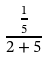<formula> <loc_0><loc_0><loc_500><loc_500>\frac { \frac { 1 } { 5 } } { 2 + 5 }</formula> 